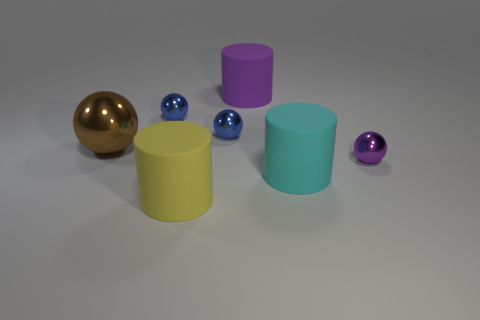Which objects in this image appear to be reflective? The gold sphere on the left appears to be highly reflective, as it shows the light source and environment reflections on its surface. 